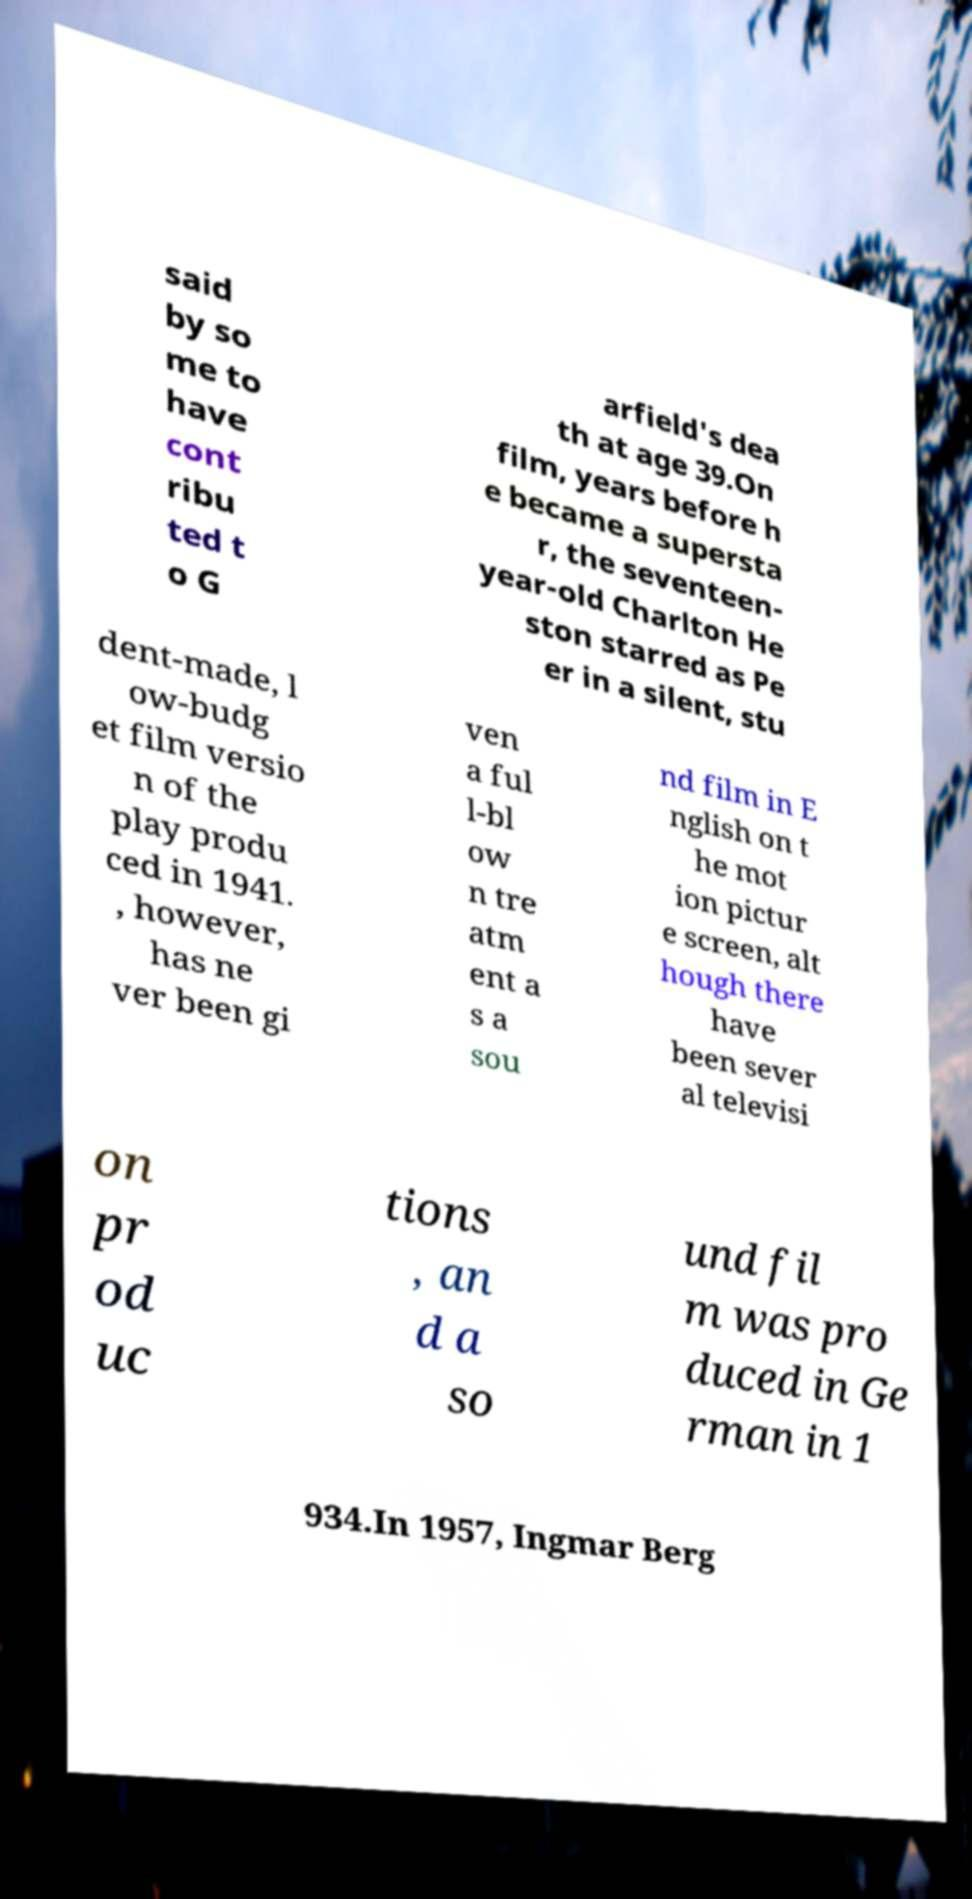Can you accurately transcribe the text from the provided image for me? said by so me to have cont ribu ted t o G arfield's dea th at age 39.On film, years before h e became a supersta r, the seventeen- year-old Charlton He ston starred as Pe er in a silent, stu dent-made, l ow-budg et film versio n of the play produ ced in 1941. , however, has ne ver been gi ven a ful l-bl ow n tre atm ent a s a sou nd film in E nglish on t he mot ion pictur e screen, alt hough there have been sever al televisi on pr od uc tions , an d a so und fil m was pro duced in Ge rman in 1 934.In 1957, Ingmar Berg 